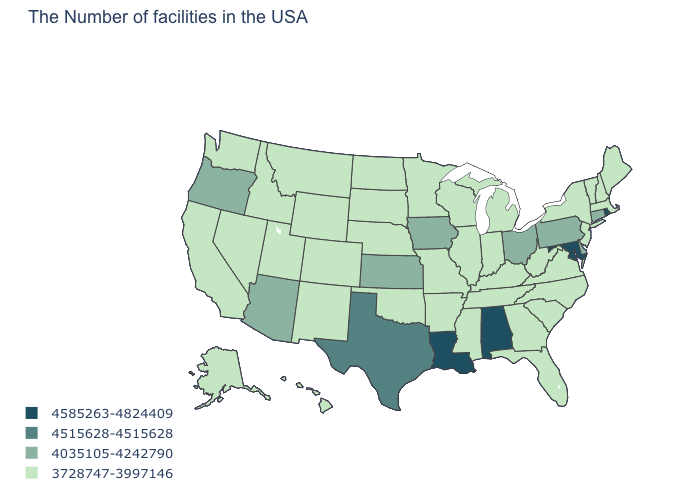What is the value of Wisconsin?
Give a very brief answer. 3728747-3997146. What is the lowest value in the USA?
Answer briefly. 3728747-3997146. Is the legend a continuous bar?
Concise answer only. No. What is the value of Mississippi?
Answer briefly. 3728747-3997146. Is the legend a continuous bar?
Short answer required. No. What is the lowest value in the South?
Quick response, please. 3728747-3997146. What is the value of Michigan?
Quick response, please. 3728747-3997146. Is the legend a continuous bar?
Concise answer only. No. What is the lowest value in states that border Oregon?
Answer briefly. 3728747-3997146. Does the first symbol in the legend represent the smallest category?
Be succinct. No. What is the highest value in the South ?
Write a very short answer. 4585263-4824409. Among the states that border Idaho , which have the highest value?
Write a very short answer. Oregon. What is the value of Florida?
Short answer required. 3728747-3997146. Name the states that have a value in the range 4585263-4824409?
Write a very short answer. Rhode Island, Maryland, Alabama, Louisiana. Name the states that have a value in the range 4035105-4242790?
Answer briefly. Connecticut, Delaware, Pennsylvania, Ohio, Iowa, Kansas, Arizona, Oregon. 